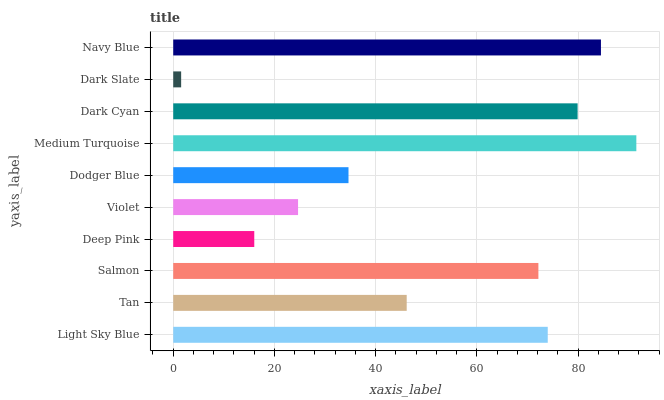Is Dark Slate the minimum?
Answer yes or no. Yes. Is Medium Turquoise the maximum?
Answer yes or no. Yes. Is Tan the minimum?
Answer yes or no. No. Is Tan the maximum?
Answer yes or no. No. Is Light Sky Blue greater than Tan?
Answer yes or no. Yes. Is Tan less than Light Sky Blue?
Answer yes or no. Yes. Is Tan greater than Light Sky Blue?
Answer yes or no. No. Is Light Sky Blue less than Tan?
Answer yes or no. No. Is Salmon the high median?
Answer yes or no. Yes. Is Tan the low median?
Answer yes or no. Yes. Is Dark Cyan the high median?
Answer yes or no. No. Is Dodger Blue the low median?
Answer yes or no. No. 